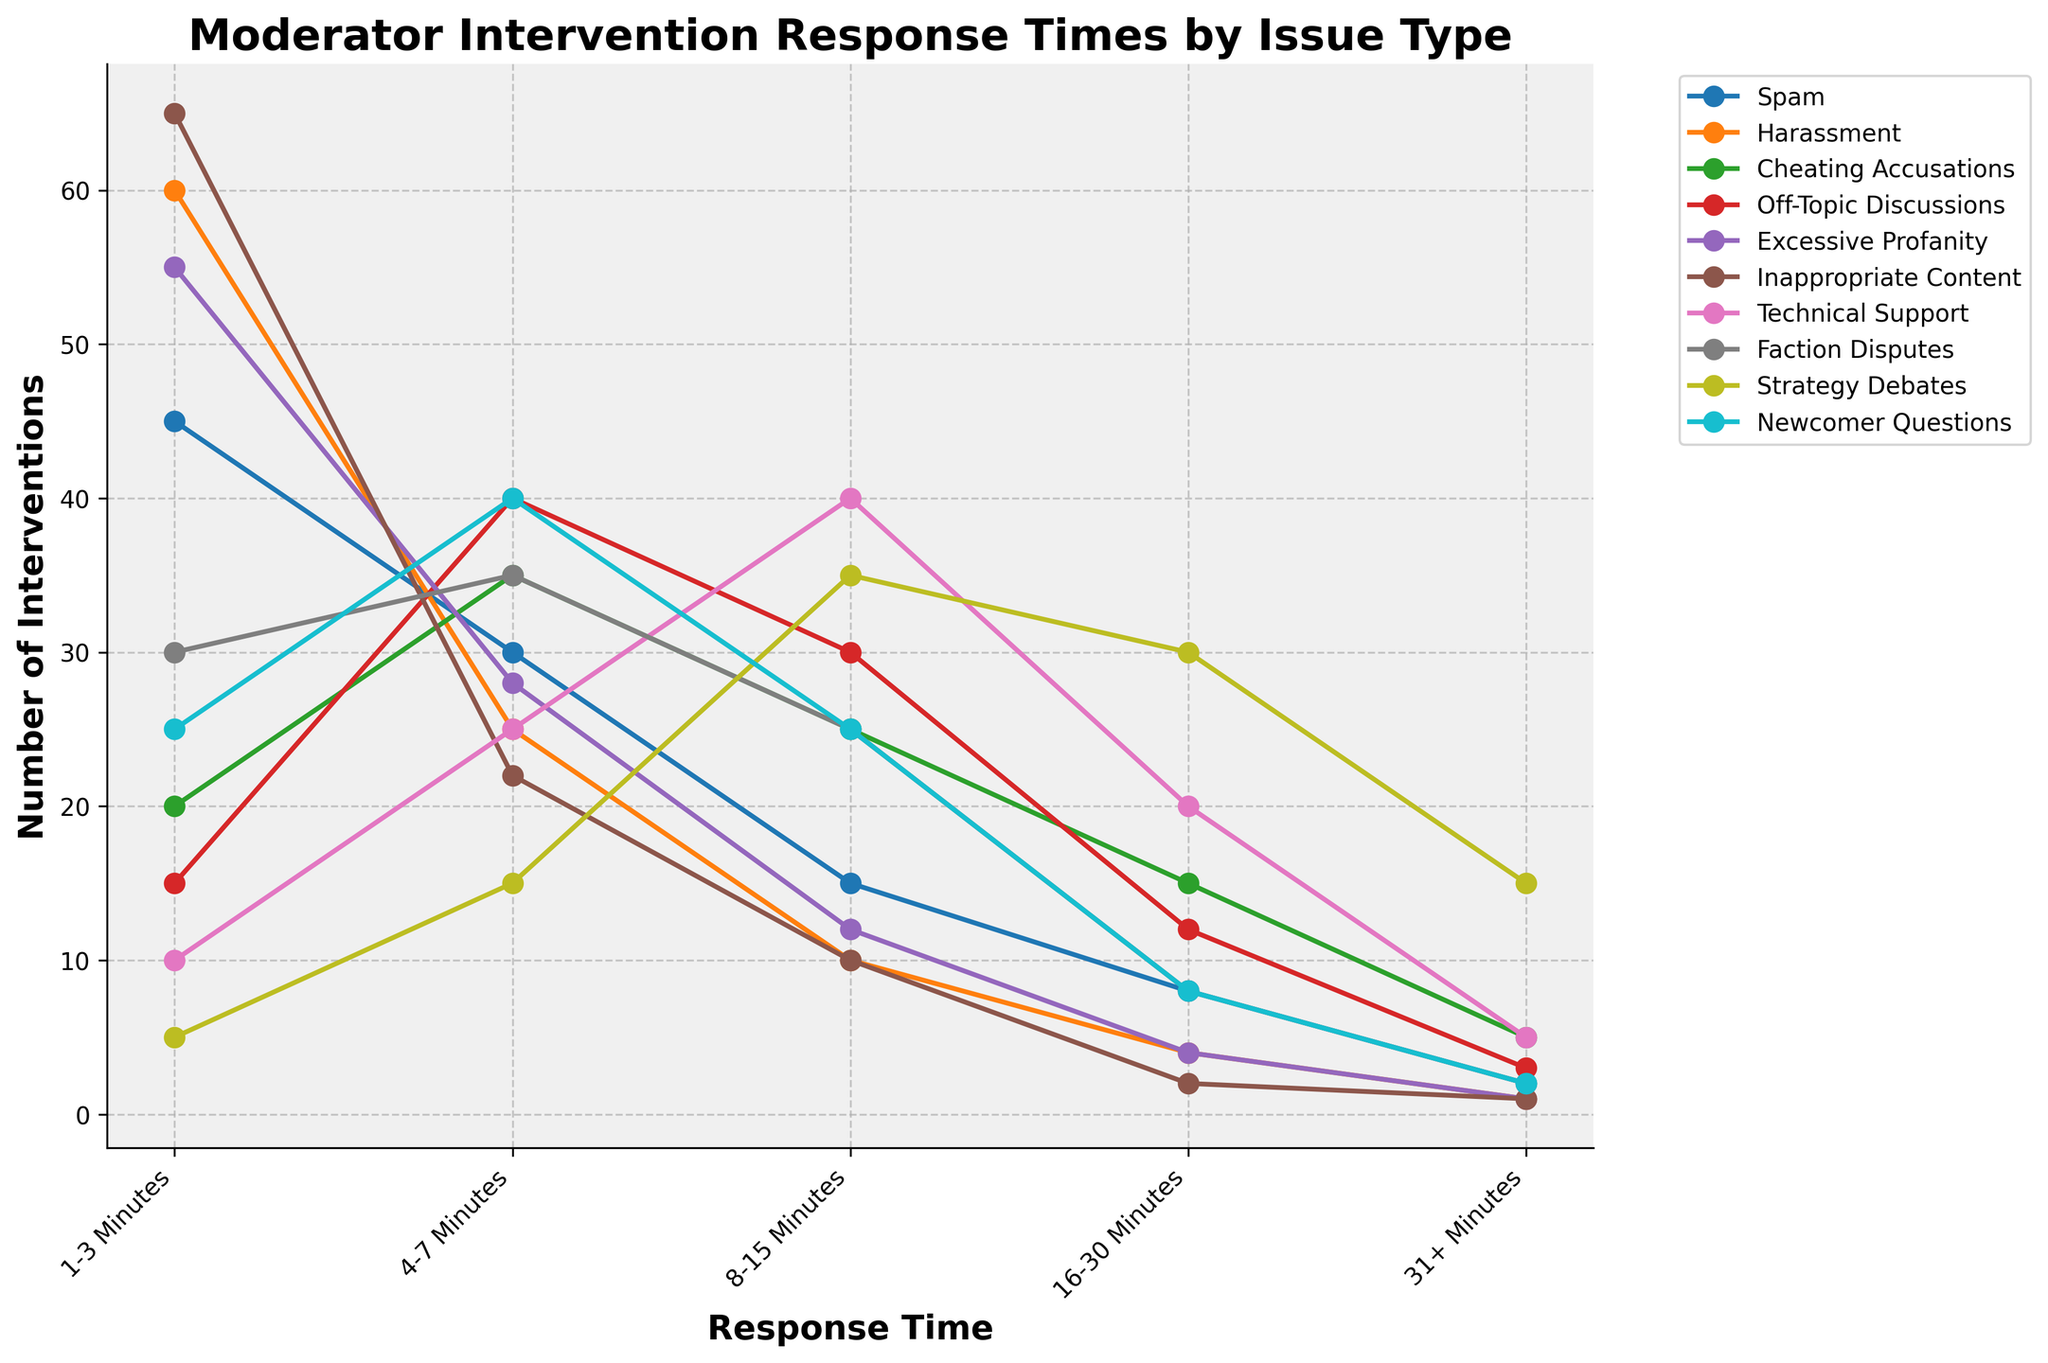Which issue type has the highest number of interventions within 1-3 minutes? Look at the different lines on the plot and identify the line that peaks highest at the 1-3 minutes category.
Answer: Inappropriate Content Which two issue types have the lowest number of interventions in the 31+ minutes category? Observe the points associated with the 31+ minutes category and identify the two points with the lowest values.
Answer: Harassment, Excessive Profanity, Inappropriate Content (Tied) What is the difference in the number of interventions between Technical Support and Strategy Debates in the 8-15 minutes category? Refer to the values in the 8-15 minutes category for both Technical Support and Strategy Debates, then calculate the difference between them (35-40).
Answer: 5 (Favoring Technical Support) Which issue type shows a significant rise in interventions from the 1-3 minutes to the 4-7 minutes category? Look at all the lines and find the one that shows a significant increase between the 1-3 minutes and 4-7 minutes categories.
Answer: Off-Topic Discussions For Harassment incidents, what is the total number of interventions for the categories 1-3 minutes, 4-7 minutes, and 8-15 minutes combined? Sum the values for Harassment in the 1-3 minutes, 4-7 minutes, and 8-15 minutes categories (60+25+10).
Answer: 95 Which issue type has consistently increasing response times across all categories? Identify any line that steadily increases from 1-3 minutes to 31+ minutes without any dips.
Answer: Strategy Debates What is the average number of interventions in the 8-15 minutes category across all issue types? Sum up the numbers for all issue types in the 8-15 minutes category and then divide by the number of issue types ((15+10+25+30+12+10+40+25+35+25)/10).
Answer: 22.7 How does the intervention frequency for Cheating Accusations change from the 1-3 minutes category to the 31+ minutes category? Track the values for Cheating Accusations from the 1-3 minutes to the 31+ minutes category, noting the increase or decrease in numbers at each step.
Answer: Decreases Which issue type drops most sharply from the 8-15 minutes to the 16-30 minutes category? Identify the line that has the steepest decline between the values in the 8-15 minutes and 16-30 minutes categories.
Answer: Technical Support What is the cumulative number of interventions in the 4-7 minutes category for Spam, Excessive Profanity, and Newcomer Questions? Sum the values for the 4-7 minutes category for Spam, Excessive Profanity, and Newcomer Questions (30+28+40).
Answer: 98 